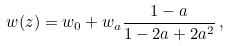<formula> <loc_0><loc_0><loc_500><loc_500>w ( z ) = w _ { 0 } + w _ { a } \frac { 1 - a } { 1 - 2 a + 2 a ^ { 2 } } \, ,</formula> 